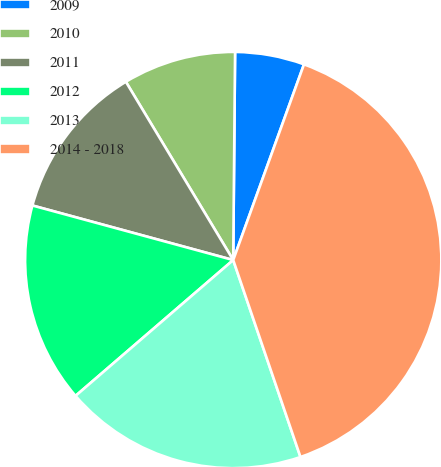<chart> <loc_0><loc_0><loc_500><loc_500><pie_chart><fcel>2009<fcel>2010<fcel>2011<fcel>2012<fcel>2013<fcel>2014 - 2018<nl><fcel>5.38%<fcel>8.77%<fcel>12.15%<fcel>15.54%<fcel>18.92%<fcel>39.24%<nl></chart> 